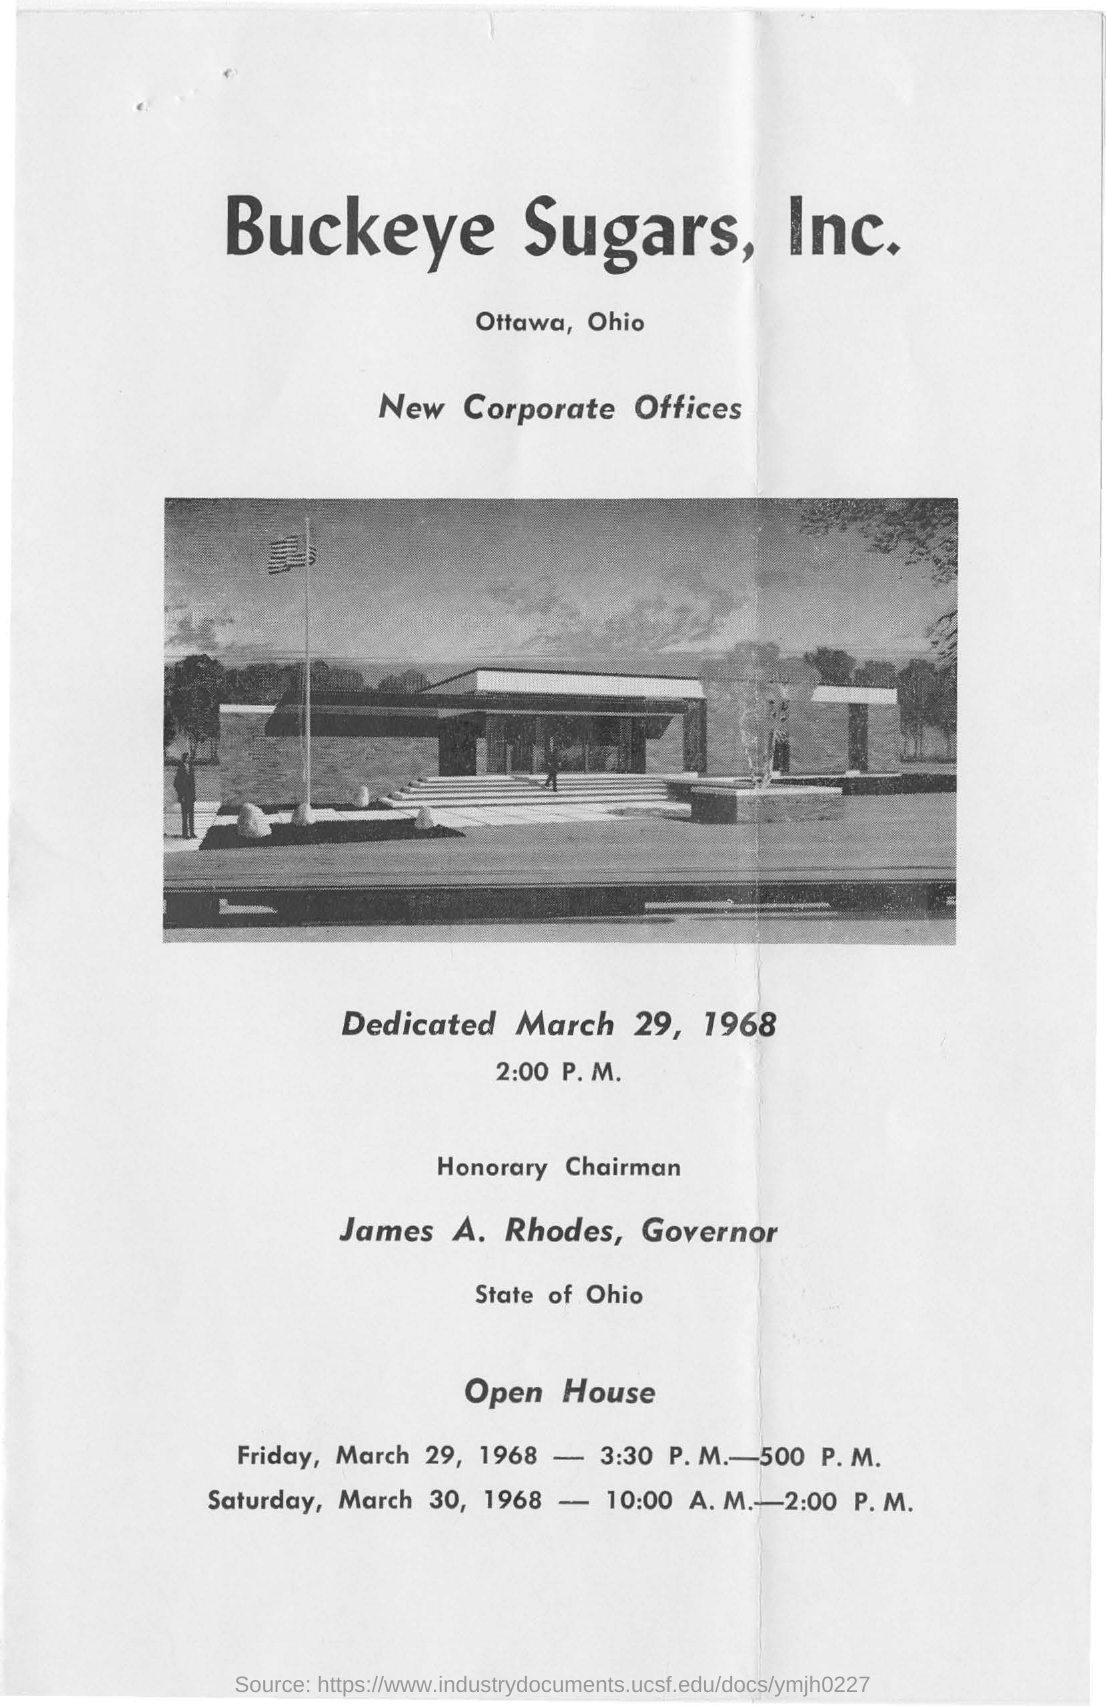Mention a couple of crucial points in this snapshot. James A. Rhodes served as the Governor of the State of Ohio. Buckeye Sugars, Inc.'s new corporate offices are being featured. 